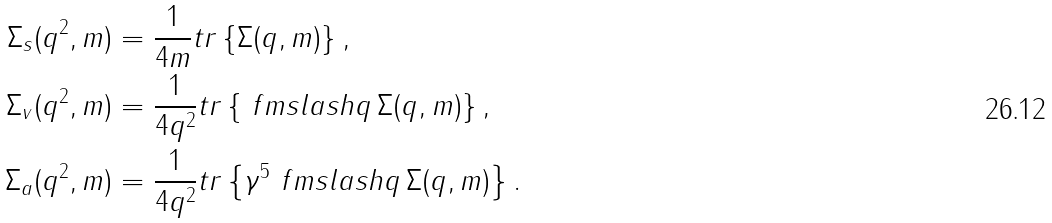Convert formula to latex. <formula><loc_0><loc_0><loc_500><loc_500>\Sigma _ { s } ( q ^ { 2 } , m ) & = \frac { 1 } { 4 m } t r \left \{ \Sigma ( q , m ) \right \} , \\ \Sigma _ { v } ( q ^ { 2 } , m ) & = \frac { 1 } { 4 q ^ { 2 } } t r \left \{ \ f m s l a s h { q } \, \Sigma ( q , m ) \right \} , \\ \Sigma _ { a } ( q ^ { 2 } , m ) & = \frac { 1 } { 4 q ^ { 2 } } t r \left \{ \gamma ^ { 5 } \ f m s l a s h { q } \, \Sigma ( q , m ) \right \} .</formula> 